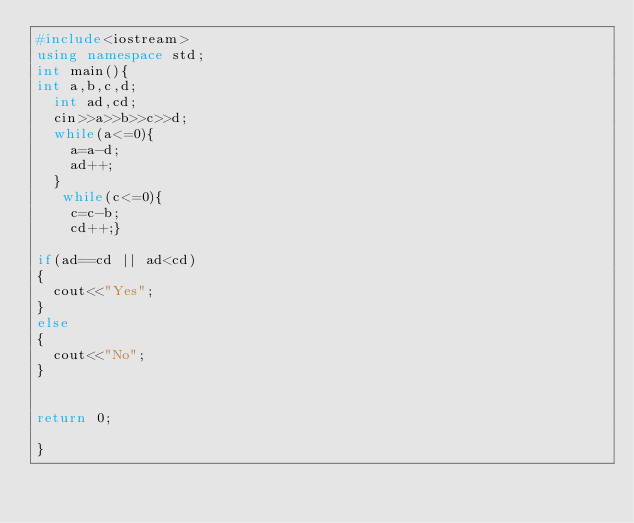<code> <loc_0><loc_0><loc_500><loc_500><_C++_>#include<iostream>
using namespace std;
int main(){
int a,b,c,d;
  int ad,cd;
  cin>>a>>b>>c>>d;
  while(a<=0){
    a=a-d;
    ad++;
  }
   while(c<=0){
    c=c-b;
    cd++;}

if(ad==cd || ad<cd)
{
  cout<<"Yes";
}
else
{
  cout<<"No";
}
  
  
return 0;
 
}</code> 